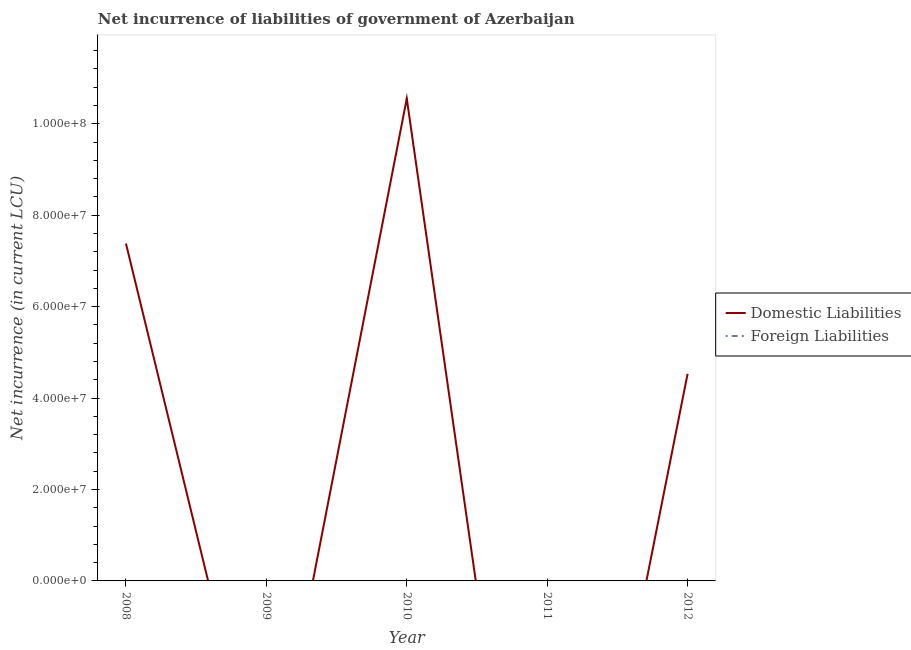Does the line corresponding to net incurrence of domestic liabilities intersect with the line corresponding to net incurrence of foreign liabilities?
Provide a succinct answer. No. What is the net incurrence of domestic liabilities in 2010?
Give a very brief answer. 1.06e+08. Across all years, what is the maximum net incurrence of domestic liabilities?
Make the answer very short. 1.06e+08. Across all years, what is the minimum net incurrence of foreign liabilities?
Keep it short and to the point. 0. What is the difference between the net incurrence of domestic liabilities in 2008 and that in 2010?
Your response must be concise. -3.17e+07. What is the difference between the net incurrence of domestic liabilities in 2009 and the net incurrence of foreign liabilities in 2012?
Provide a succinct answer. 0. What is the ratio of the net incurrence of domestic liabilities in 2008 to that in 2012?
Ensure brevity in your answer.  1.63. What is the difference between the highest and the second highest net incurrence of domestic liabilities?
Provide a succinct answer. 3.17e+07. What is the difference between the highest and the lowest net incurrence of domestic liabilities?
Your response must be concise. 1.06e+08. Is the sum of the net incurrence of domestic liabilities in 2008 and 2010 greater than the maximum net incurrence of foreign liabilities across all years?
Provide a succinct answer. Yes. Is the net incurrence of domestic liabilities strictly greater than the net incurrence of foreign liabilities over the years?
Make the answer very short. Yes. How many lines are there?
Offer a terse response. 1. How many years are there in the graph?
Give a very brief answer. 5. Does the graph contain grids?
Your answer should be compact. No. Where does the legend appear in the graph?
Your response must be concise. Center right. How are the legend labels stacked?
Provide a succinct answer. Vertical. What is the title of the graph?
Offer a terse response. Net incurrence of liabilities of government of Azerbaijan. Does "Quasi money growth" appear as one of the legend labels in the graph?
Provide a short and direct response. No. What is the label or title of the X-axis?
Provide a short and direct response. Year. What is the label or title of the Y-axis?
Your answer should be very brief. Net incurrence (in current LCU). What is the Net incurrence (in current LCU) of Domestic Liabilities in 2008?
Ensure brevity in your answer.  7.38e+07. What is the Net incurrence (in current LCU) in Foreign Liabilities in 2009?
Provide a succinct answer. 0. What is the Net incurrence (in current LCU) of Domestic Liabilities in 2010?
Provide a succinct answer. 1.06e+08. What is the Net incurrence (in current LCU) in Foreign Liabilities in 2010?
Provide a succinct answer. 0. What is the Net incurrence (in current LCU) in Domestic Liabilities in 2011?
Make the answer very short. 0. What is the Net incurrence (in current LCU) in Domestic Liabilities in 2012?
Your answer should be very brief. 4.53e+07. What is the Net incurrence (in current LCU) in Foreign Liabilities in 2012?
Provide a short and direct response. 0. Across all years, what is the maximum Net incurrence (in current LCU) of Domestic Liabilities?
Ensure brevity in your answer.  1.06e+08. Across all years, what is the minimum Net incurrence (in current LCU) in Domestic Liabilities?
Keep it short and to the point. 0. What is the total Net incurrence (in current LCU) of Domestic Liabilities in the graph?
Make the answer very short. 2.25e+08. What is the difference between the Net incurrence (in current LCU) in Domestic Liabilities in 2008 and that in 2010?
Your answer should be very brief. -3.17e+07. What is the difference between the Net incurrence (in current LCU) in Domestic Liabilities in 2008 and that in 2012?
Offer a terse response. 2.85e+07. What is the difference between the Net incurrence (in current LCU) in Domestic Liabilities in 2010 and that in 2012?
Provide a succinct answer. 6.02e+07. What is the average Net incurrence (in current LCU) of Domestic Liabilities per year?
Make the answer very short. 4.49e+07. What is the average Net incurrence (in current LCU) in Foreign Liabilities per year?
Provide a succinct answer. 0. What is the ratio of the Net incurrence (in current LCU) in Domestic Liabilities in 2008 to that in 2010?
Offer a terse response. 0.7. What is the ratio of the Net incurrence (in current LCU) in Domestic Liabilities in 2008 to that in 2012?
Give a very brief answer. 1.63. What is the ratio of the Net incurrence (in current LCU) in Domestic Liabilities in 2010 to that in 2012?
Keep it short and to the point. 2.33. What is the difference between the highest and the second highest Net incurrence (in current LCU) of Domestic Liabilities?
Your answer should be compact. 3.17e+07. What is the difference between the highest and the lowest Net incurrence (in current LCU) in Domestic Liabilities?
Your answer should be compact. 1.06e+08. 